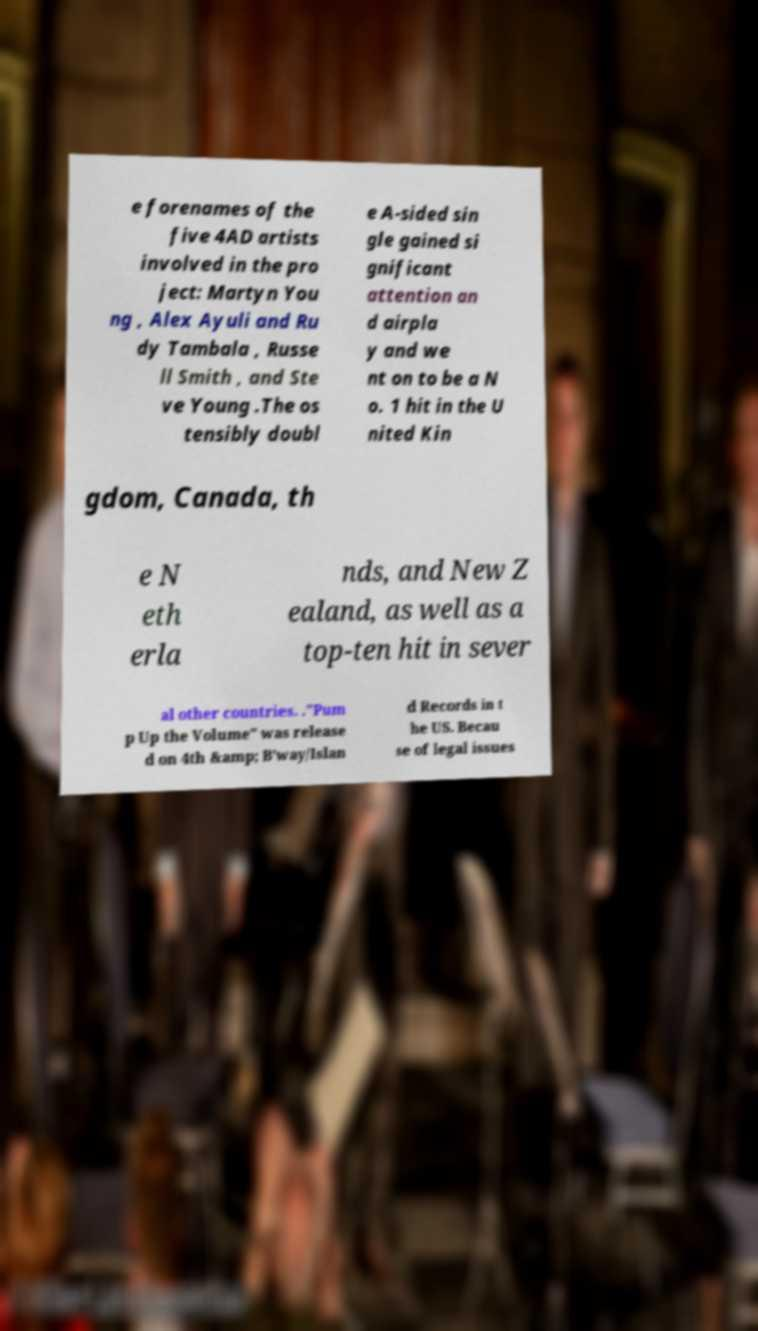What messages or text are displayed in this image? I need them in a readable, typed format. e forenames of the five 4AD artists involved in the pro ject: Martyn You ng , Alex Ayuli and Ru dy Tambala , Russe ll Smith , and Ste ve Young .The os tensibly doubl e A-sided sin gle gained si gnificant attention an d airpla y and we nt on to be a N o. 1 hit in the U nited Kin gdom, Canada, th e N eth erla nds, and New Z ealand, as well as a top-ten hit in sever al other countries. ."Pum p Up the Volume" was release d on 4th &amp; B’way/Islan d Records in t he US. Becau se of legal issues 